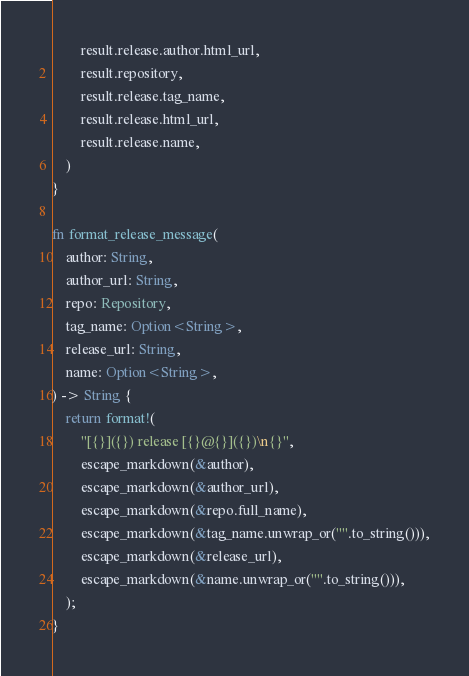Convert code to text. <code><loc_0><loc_0><loc_500><loc_500><_Rust_>        result.release.author.html_url,
        result.repository,
        result.release.tag_name,
        result.release.html_url,
        result.release.name,
    )
}

fn format_release_message(
    author: String,
    author_url: String,
    repo: Repository,
    tag_name: Option<String>,
    release_url: String,
    name: Option<String>,
) -> String {
    return format!(
        "[{}]({}) release [{}@{}]({})\n{}",
        escape_markdown(&author),
        escape_markdown(&author_url),
        escape_markdown(&repo.full_name),
        escape_markdown(&tag_name.unwrap_or("".to_string())),
        escape_markdown(&release_url),
        escape_markdown(&name.unwrap_or("".to_string())),
    );
}
</code> 